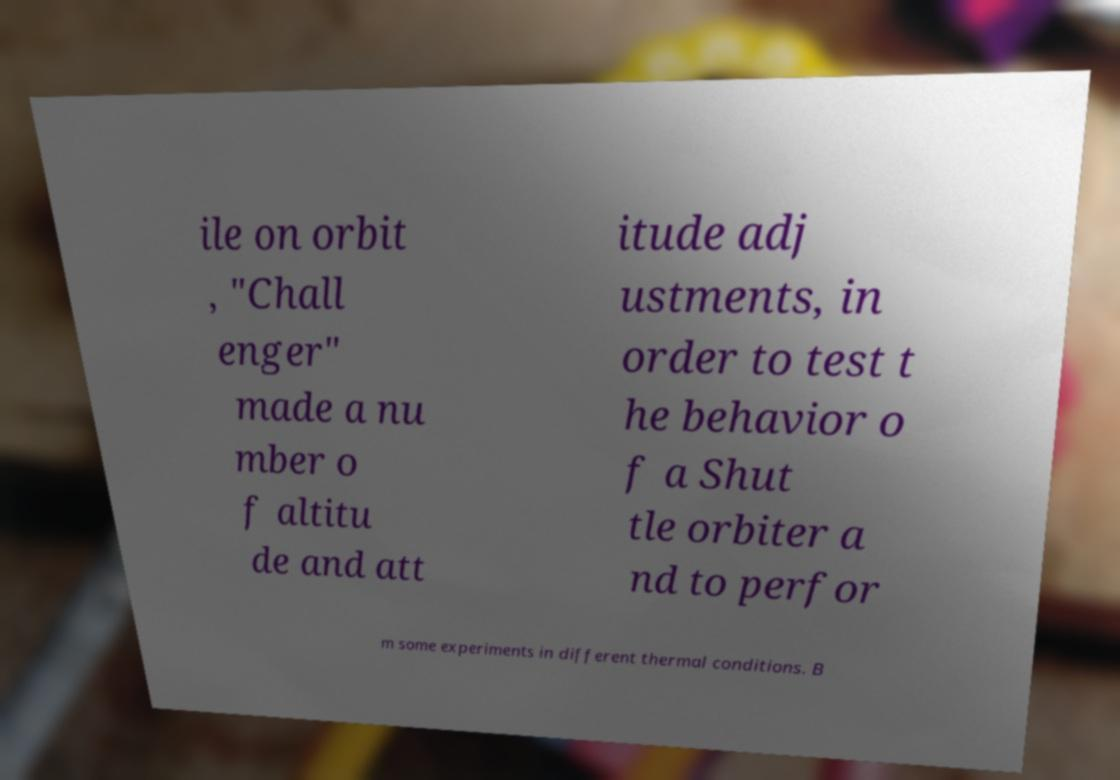Please identify and transcribe the text found in this image. ile on orbit , "Chall enger" made a nu mber o f altitu de and att itude adj ustments, in order to test t he behavior o f a Shut tle orbiter a nd to perfor m some experiments in different thermal conditions. B 